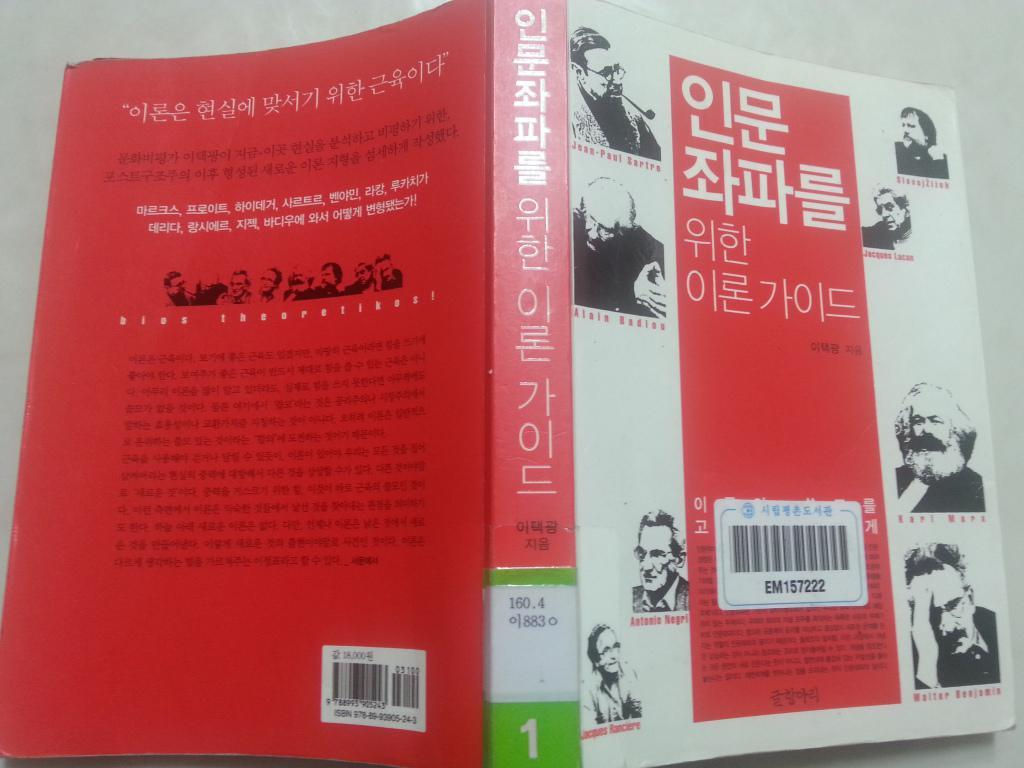<image>
Present a compact description of the photo's key features. The book in Korean language has a bar code number EM157222. 